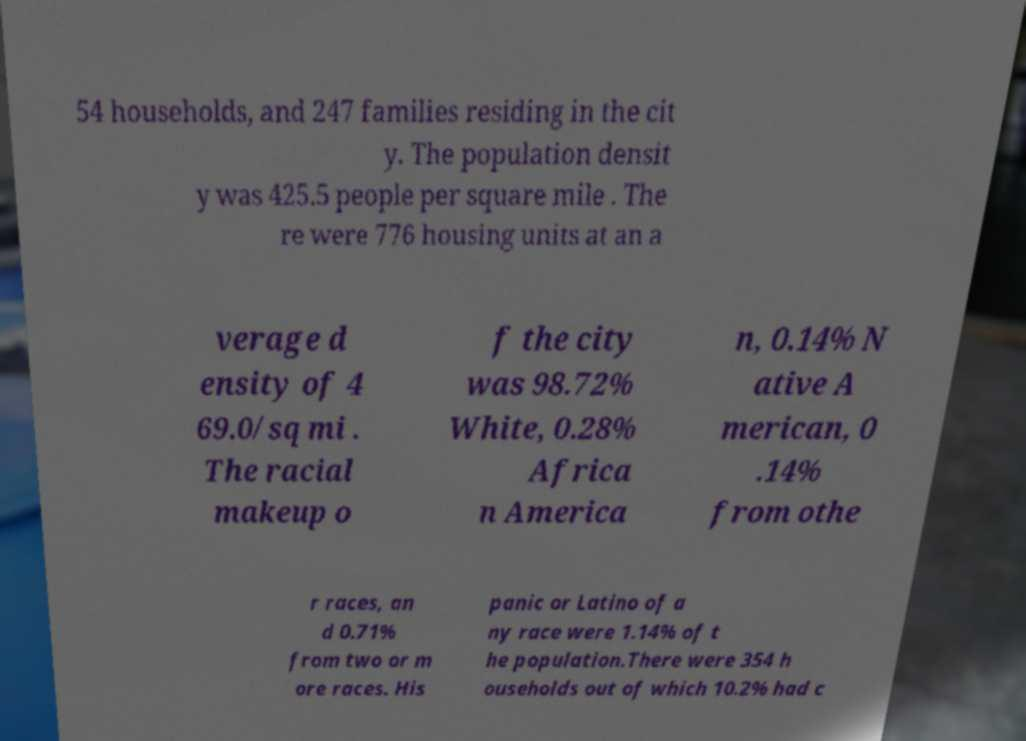I need the written content from this picture converted into text. Can you do that? 54 households, and 247 families residing in the cit y. The population densit y was 425.5 people per square mile . The re were 776 housing units at an a verage d ensity of 4 69.0/sq mi . The racial makeup o f the city was 98.72% White, 0.28% Africa n America n, 0.14% N ative A merican, 0 .14% from othe r races, an d 0.71% from two or m ore races. His panic or Latino of a ny race were 1.14% of t he population.There were 354 h ouseholds out of which 10.2% had c 